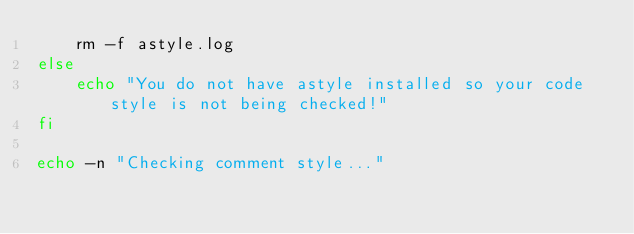<code> <loc_0><loc_0><loc_500><loc_500><_Bash_>	rm -f astyle.log
else
	echo "You do not have astyle installed so your code style is not being checked!"
fi

echo -n "Checking comment style..."
</code> 